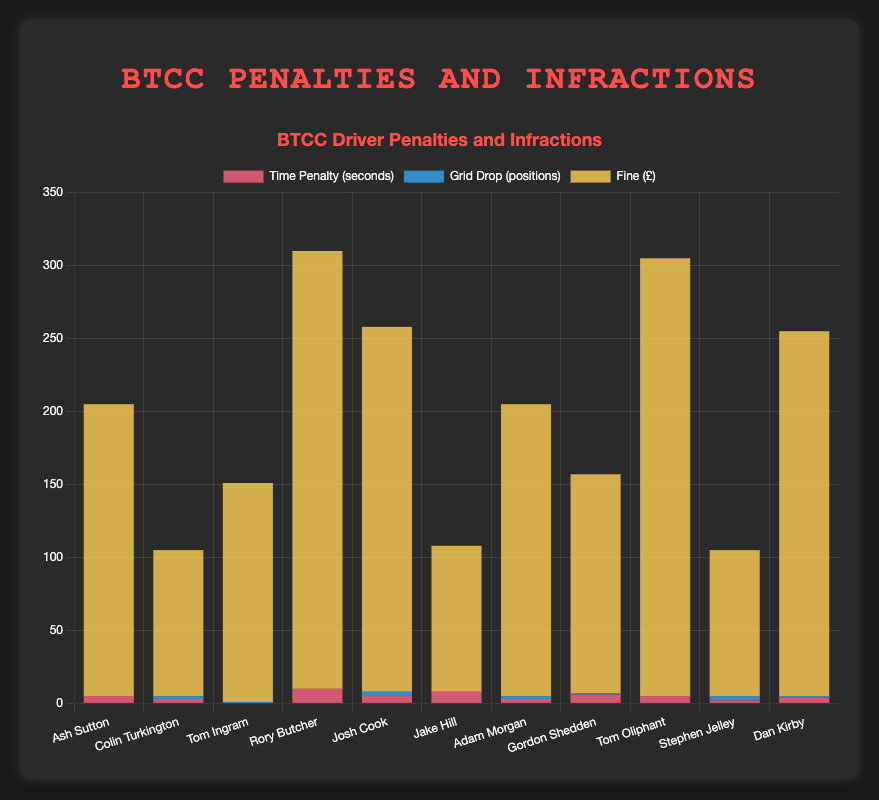What is the total fine amount for Tom Oliphant and Rory Butcher combined? To find the total fine amount, look at the fine values for Tom Oliphant (£300) and Rory Butcher (£300). Add these amounts together: 300 + 300 = 600
Answer: 600 Which driver received the highest time penalty and how much was it? To determine the highest time penalty, compare the time penalty values for all drivers. Rory Butcher received the highest time penalty of 10 seconds.
Answer: Rory Butcher, 10 seconds How many drivers received a grid drop penalty and what is the combined sum of all grid drop penalties? Count the drivers with a grid drop greater than 0 and sum their grid drop values. There are 5 drivers with grid drop penalties: Colin Turkington (2), Tom Ingram (1), Josh Cook (3), Adam Morgan (2), and Stephen Jelley (3). Combined sum: 2 + 1 + 3 + 2 + 3 = 11
Answer: 5 drivers, 11 grid drops Which penalty type shows the most variance in penalties across drivers? Compare the distribution of penalties for time penalty, grid drop, and fine. Time penalties range from 0 to 10 seconds, grid drops range from 0 to 3 positions, and fines range from £100 to £300. Time penalties have the widest range/variance.
Answer: Time penalty Compare Dan Kirby's total fine amount with Josh Cook's total fine amount. Who had the higher fine and by how much? Dan Kirby's fine is £250, while Josh Cook's fine is also £250. The fines are equal, there is no difference.
Answer: No difference Who had the greatest combined penalty (sum of time penalty, grid drop, and fine) and what was the combined value? Compute the combined penalty for each driver by adding their time penalty, grid drop, and fine. Rory Butcher’s combined penalty is: 10 (time penalty) + 0 (grid drop) + 300 (fine) = 310. Other drivers have lower combined penalties.
Answer: Rory Butcher, 310 What is the average time penalty imposed on all drivers? Sum all time penalties: 5 + 3 + 0 + 10 + 5 + 8 + 3 + 6 + 5 + 2 + 4 = 51. There are 11 drivers, so the average time penalty is 51/11 = 4.64 seconds.
Answer: 4.64 seconds Which two drivers have the most similar total infractions (sum of time penalty, grid drop, and fine)? Calculate the total infractions for each driver and compare. Dan Kirby and Josh Cook both have sums of 255, which is the most similar.
Answer: Dan Kirby and Josh Cook How does Ash Sutton's total fine compare to the total fine of Stephen Jelley? Ash Sutton's total fine is £200, and Stephen Jelley's total fine is £100. Ash Sutton's fine is £100 more than Stephen Jelley's fine.
Answer: Ash Sutton, £100 more What is the average grid drop penalty imposed on the drivers who received grid drops? Sum the grid drops for affected drivers: 2 + 1 + 3 + 2 + 3 = 11. There are 5 drivers with grid drops, so the average is 11/5 = 2.2 grid drops.
Answer: 2.2 grid drops 